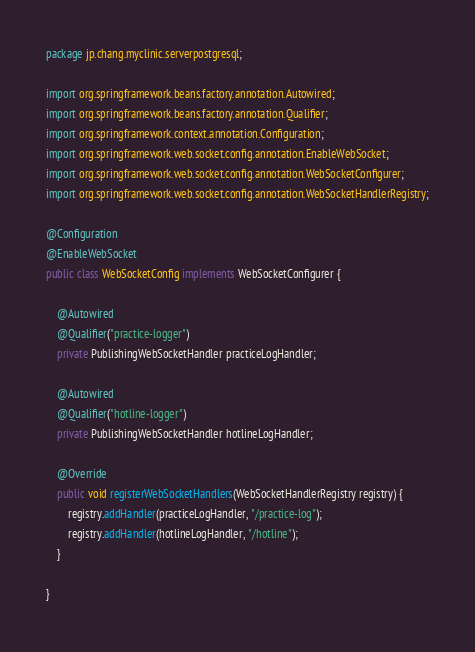<code> <loc_0><loc_0><loc_500><loc_500><_Java_>package jp.chang.myclinic.serverpostgresql;

import org.springframework.beans.factory.annotation.Autowired;
import org.springframework.beans.factory.annotation.Qualifier;
import org.springframework.context.annotation.Configuration;
import org.springframework.web.socket.config.annotation.EnableWebSocket;
import org.springframework.web.socket.config.annotation.WebSocketConfigurer;
import org.springframework.web.socket.config.annotation.WebSocketHandlerRegistry;

@Configuration
@EnableWebSocket
public class WebSocketConfig implements WebSocketConfigurer {

    @Autowired
    @Qualifier("practice-logger")
    private PublishingWebSocketHandler practiceLogHandler;

    @Autowired
    @Qualifier("hotline-logger")
    private PublishingWebSocketHandler hotlineLogHandler;

    @Override
    public void registerWebSocketHandlers(WebSocketHandlerRegistry registry) {
        registry.addHandler(practiceLogHandler, "/practice-log");
        registry.addHandler(hotlineLogHandler, "/hotline");
    }

}
</code> 